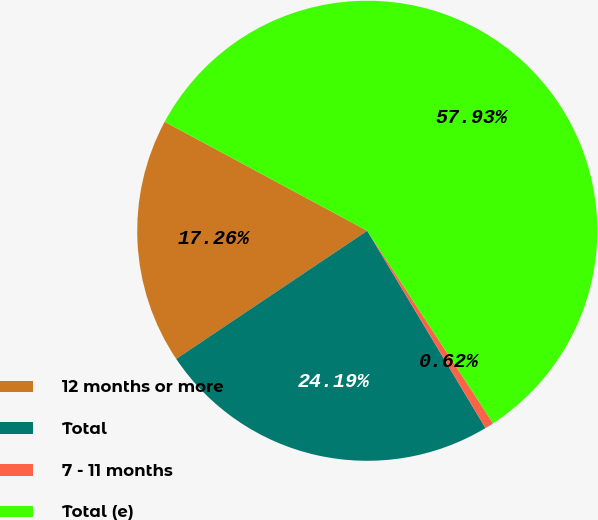<chart> <loc_0><loc_0><loc_500><loc_500><pie_chart><fcel>12 months or more<fcel>Total<fcel>7 - 11 months<fcel>Total (e)<nl><fcel>17.26%<fcel>24.19%<fcel>0.62%<fcel>57.93%<nl></chart> 